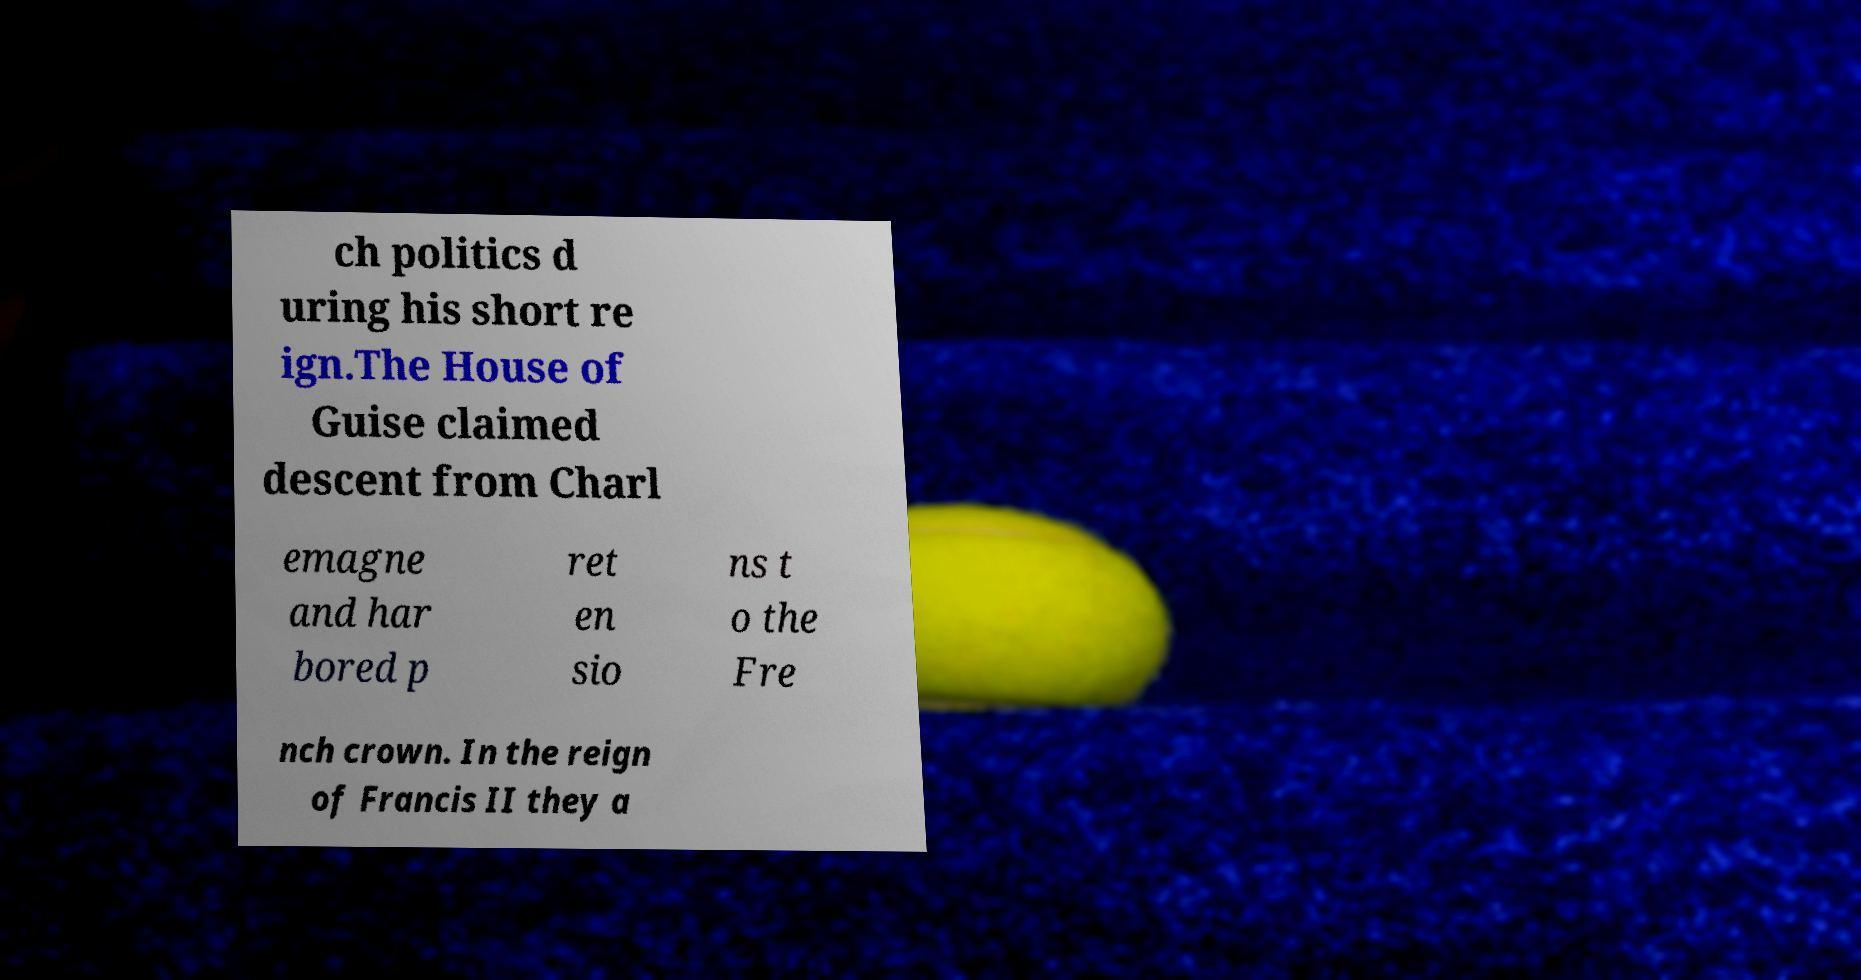For documentation purposes, I need the text within this image transcribed. Could you provide that? ch politics d uring his short re ign.The House of Guise claimed descent from Charl emagne and har bored p ret en sio ns t o the Fre nch crown. In the reign of Francis II they a 